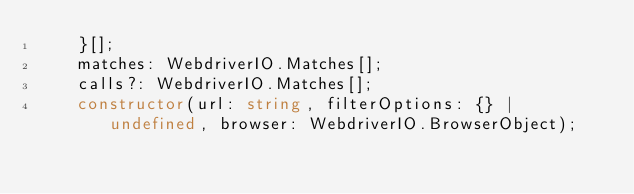<code> <loc_0><loc_0><loc_500><loc_500><_TypeScript_>    }[];
    matches: WebdriverIO.Matches[];
    calls?: WebdriverIO.Matches[];
    constructor(url: string, filterOptions: {} | undefined, browser: WebdriverIO.BrowserObject);</code> 